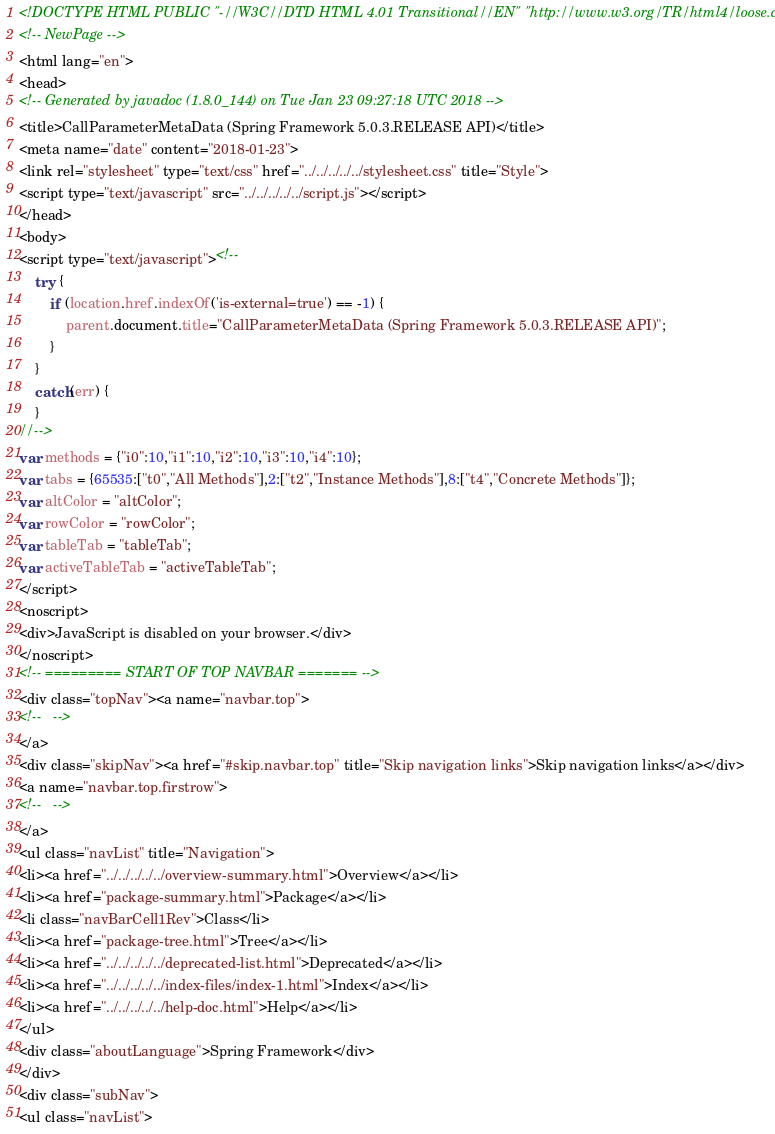Convert code to text. <code><loc_0><loc_0><loc_500><loc_500><_HTML_><!DOCTYPE HTML PUBLIC "-//W3C//DTD HTML 4.01 Transitional//EN" "http://www.w3.org/TR/html4/loose.dtd">
<!-- NewPage -->
<html lang="en">
<head>
<!-- Generated by javadoc (1.8.0_144) on Tue Jan 23 09:27:18 UTC 2018 -->
<title>CallParameterMetaData (Spring Framework 5.0.3.RELEASE API)</title>
<meta name="date" content="2018-01-23">
<link rel="stylesheet" type="text/css" href="../../../../../stylesheet.css" title="Style">
<script type="text/javascript" src="../../../../../script.js"></script>
</head>
<body>
<script type="text/javascript"><!--
    try {
        if (location.href.indexOf('is-external=true') == -1) {
            parent.document.title="CallParameterMetaData (Spring Framework 5.0.3.RELEASE API)";
        }
    }
    catch(err) {
    }
//-->
var methods = {"i0":10,"i1":10,"i2":10,"i3":10,"i4":10};
var tabs = {65535:["t0","All Methods"],2:["t2","Instance Methods"],8:["t4","Concrete Methods"]};
var altColor = "altColor";
var rowColor = "rowColor";
var tableTab = "tableTab";
var activeTableTab = "activeTableTab";
</script>
<noscript>
<div>JavaScript is disabled on your browser.</div>
</noscript>
<!-- ========= START OF TOP NAVBAR ======= -->
<div class="topNav"><a name="navbar.top">
<!--   -->
</a>
<div class="skipNav"><a href="#skip.navbar.top" title="Skip navigation links">Skip navigation links</a></div>
<a name="navbar.top.firstrow">
<!--   -->
</a>
<ul class="navList" title="Navigation">
<li><a href="../../../../../overview-summary.html">Overview</a></li>
<li><a href="package-summary.html">Package</a></li>
<li class="navBarCell1Rev">Class</li>
<li><a href="package-tree.html">Tree</a></li>
<li><a href="../../../../../deprecated-list.html">Deprecated</a></li>
<li><a href="../../../../../index-files/index-1.html">Index</a></li>
<li><a href="../../../../../help-doc.html">Help</a></li>
</ul>
<div class="aboutLanguage">Spring Framework</div>
</div>
<div class="subNav">
<ul class="navList"></code> 